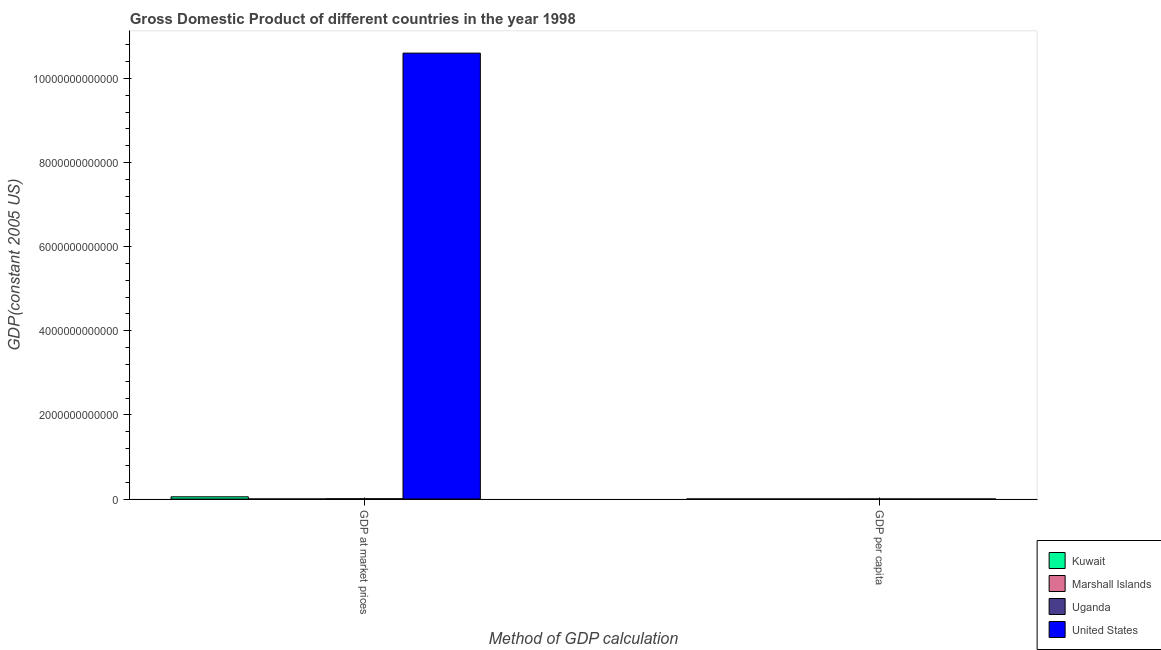How many different coloured bars are there?
Provide a succinct answer. 4. Are the number of bars per tick equal to the number of legend labels?
Make the answer very short. Yes. How many bars are there on the 1st tick from the left?
Give a very brief answer. 4. How many bars are there on the 1st tick from the right?
Your answer should be compact. 4. What is the label of the 1st group of bars from the left?
Your answer should be very brief. GDP at market prices. What is the gdp at market prices in Kuwait?
Make the answer very short. 5.30e+1. Across all countries, what is the maximum gdp at market prices?
Give a very brief answer. 1.06e+13. Across all countries, what is the minimum gdp per capita?
Your answer should be compact. 261.82. In which country was the gdp per capita minimum?
Offer a terse response. Uganda. What is the total gdp per capita in the graph?
Your answer should be very brief. 7.10e+04. What is the difference between the gdp at market prices in Marshall Islands and that in United States?
Offer a terse response. -1.06e+13. What is the difference between the gdp per capita in Uganda and the gdp at market prices in United States?
Offer a very short reply. -1.06e+13. What is the average gdp per capita per country?
Offer a very short reply. 1.77e+04. What is the difference between the gdp per capita and gdp at market prices in United States?
Offer a terse response. -1.06e+13. What is the ratio of the gdp at market prices in United States to that in Uganda?
Provide a short and direct response. 1812.95. In how many countries, is the gdp per capita greater than the average gdp per capita taken over all countries?
Keep it short and to the point. 2. What does the 2nd bar from the left in GDP per capita represents?
Your answer should be very brief. Marshall Islands. What does the 2nd bar from the right in GDP per capita represents?
Provide a short and direct response. Uganda. How many bars are there?
Provide a succinct answer. 8. Are all the bars in the graph horizontal?
Your answer should be very brief. No. What is the difference between two consecutive major ticks on the Y-axis?
Your answer should be very brief. 2.00e+12. Where does the legend appear in the graph?
Offer a very short reply. Bottom right. How are the legend labels stacked?
Ensure brevity in your answer.  Vertical. What is the title of the graph?
Offer a terse response. Gross Domestic Product of different countries in the year 1998. What is the label or title of the X-axis?
Provide a succinct answer. Method of GDP calculation. What is the label or title of the Y-axis?
Your answer should be very brief. GDP(constant 2005 US). What is the GDP(constant 2005 US) of Kuwait in GDP at market prices?
Make the answer very short. 5.30e+1. What is the GDP(constant 2005 US) of Marshall Islands in GDP at market prices?
Your answer should be compact. 1.20e+08. What is the GDP(constant 2005 US) of Uganda in GDP at market prices?
Make the answer very short. 5.85e+09. What is the GDP(constant 2005 US) of United States in GDP at market prices?
Your answer should be very brief. 1.06e+13. What is the GDP(constant 2005 US) of Kuwait in GDP per capita?
Offer a terse response. 3.00e+04. What is the GDP(constant 2005 US) in Marshall Islands in GDP per capita?
Your answer should be compact. 2307.91. What is the GDP(constant 2005 US) in Uganda in GDP per capita?
Provide a succinct answer. 261.82. What is the GDP(constant 2005 US) of United States in GDP per capita?
Provide a succinct answer. 3.84e+04. Across all Method of GDP calculation, what is the maximum GDP(constant 2005 US) of Kuwait?
Your answer should be compact. 5.30e+1. Across all Method of GDP calculation, what is the maximum GDP(constant 2005 US) in Marshall Islands?
Provide a succinct answer. 1.20e+08. Across all Method of GDP calculation, what is the maximum GDP(constant 2005 US) in Uganda?
Your answer should be very brief. 5.85e+09. Across all Method of GDP calculation, what is the maximum GDP(constant 2005 US) in United States?
Your response must be concise. 1.06e+13. Across all Method of GDP calculation, what is the minimum GDP(constant 2005 US) in Kuwait?
Provide a succinct answer. 3.00e+04. Across all Method of GDP calculation, what is the minimum GDP(constant 2005 US) of Marshall Islands?
Provide a short and direct response. 2307.91. Across all Method of GDP calculation, what is the minimum GDP(constant 2005 US) of Uganda?
Your response must be concise. 261.82. Across all Method of GDP calculation, what is the minimum GDP(constant 2005 US) of United States?
Give a very brief answer. 3.84e+04. What is the total GDP(constant 2005 US) of Kuwait in the graph?
Offer a terse response. 5.30e+1. What is the total GDP(constant 2005 US) of Marshall Islands in the graph?
Offer a very short reply. 1.20e+08. What is the total GDP(constant 2005 US) in Uganda in the graph?
Keep it short and to the point. 5.85e+09. What is the total GDP(constant 2005 US) in United States in the graph?
Your response must be concise. 1.06e+13. What is the difference between the GDP(constant 2005 US) of Kuwait in GDP at market prices and that in GDP per capita?
Give a very brief answer. 5.30e+1. What is the difference between the GDP(constant 2005 US) in Marshall Islands in GDP at market prices and that in GDP per capita?
Make the answer very short. 1.20e+08. What is the difference between the GDP(constant 2005 US) of Uganda in GDP at market prices and that in GDP per capita?
Offer a terse response. 5.85e+09. What is the difference between the GDP(constant 2005 US) in United States in GDP at market prices and that in GDP per capita?
Make the answer very short. 1.06e+13. What is the difference between the GDP(constant 2005 US) of Kuwait in GDP at market prices and the GDP(constant 2005 US) of Marshall Islands in GDP per capita?
Your answer should be very brief. 5.30e+1. What is the difference between the GDP(constant 2005 US) in Kuwait in GDP at market prices and the GDP(constant 2005 US) in Uganda in GDP per capita?
Give a very brief answer. 5.30e+1. What is the difference between the GDP(constant 2005 US) in Kuwait in GDP at market prices and the GDP(constant 2005 US) in United States in GDP per capita?
Provide a succinct answer. 5.30e+1. What is the difference between the GDP(constant 2005 US) of Marshall Islands in GDP at market prices and the GDP(constant 2005 US) of Uganda in GDP per capita?
Offer a terse response. 1.20e+08. What is the difference between the GDP(constant 2005 US) in Marshall Islands in GDP at market prices and the GDP(constant 2005 US) in United States in GDP per capita?
Ensure brevity in your answer.  1.20e+08. What is the difference between the GDP(constant 2005 US) in Uganda in GDP at market prices and the GDP(constant 2005 US) in United States in GDP per capita?
Your answer should be very brief. 5.85e+09. What is the average GDP(constant 2005 US) of Kuwait per Method of GDP calculation?
Ensure brevity in your answer.  2.65e+1. What is the average GDP(constant 2005 US) of Marshall Islands per Method of GDP calculation?
Provide a short and direct response. 5.99e+07. What is the average GDP(constant 2005 US) of Uganda per Method of GDP calculation?
Keep it short and to the point. 2.92e+09. What is the average GDP(constant 2005 US) of United States per Method of GDP calculation?
Your answer should be very brief. 5.30e+12. What is the difference between the GDP(constant 2005 US) in Kuwait and GDP(constant 2005 US) in Marshall Islands in GDP at market prices?
Offer a terse response. 5.28e+1. What is the difference between the GDP(constant 2005 US) in Kuwait and GDP(constant 2005 US) in Uganda in GDP at market prices?
Your response must be concise. 4.71e+1. What is the difference between the GDP(constant 2005 US) of Kuwait and GDP(constant 2005 US) of United States in GDP at market prices?
Keep it short and to the point. -1.05e+13. What is the difference between the GDP(constant 2005 US) of Marshall Islands and GDP(constant 2005 US) of Uganda in GDP at market prices?
Keep it short and to the point. -5.73e+09. What is the difference between the GDP(constant 2005 US) in Marshall Islands and GDP(constant 2005 US) in United States in GDP at market prices?
Provide a short and direct response. -1.06e+13. What is the difference between the GDP(constant 2005 US) in Uganda and GDP(constant 2005 US) in United States in GDP at market prices?
Your answer should be compact. -1.06e+13. What is the difference between the GDP(constant 2005 US) in Kuwait and GDP(constant 2005 US) in Marshall Islands in GDP per capita?
Provide a short and direct response. 2.77e+04. What is the difference between the GDP(constant 2005 US) in Kuwait and GDP(constant 2005 US) in Uganda in GDP per capita?
Keep it short and to the point. 2.97e+04. What is the difference between the GDP(constant 2005 US) of Kuwait and GDP(constant 2005 US) of United States in GDP per capita?
Your response must be concise. -8455.79. What is the difference between the GDP(constant 2005 US) in Marshall Islands and GDP(constant 2005 US) in Uganda in GDP per capita?
Your answer should be very brief. 2046.09. What is the difference between the GDP(constant 2005 US) in Marshall Islands and GDP(constant 2005 US) in United States in GDP per capita?
Offer a very short reply. -3.61e+04. What is the difference between the GDP(constant 2005 US) in Uganda and GDP(constant 2005 US) in United States in GDP per capita?
Make the answer very short. -3.82e+04. What is the ratio of the GDP(constant 2005 US) of Kuwait in GDP at market prices to that in GDP per capita?
Make the answer very short. 1.77e+06. What is the ratio of the GDP(constant 2005 US) of Marshall Islands in GDP at market prices to that in GDP per capita?
Your response must be concise. 5.19e+04. What is the ratio of the GDP(constant 2005 US) of Uganda in GDP at market prices to that in GDP per capita?
Keep it short and to the point. 2.23e+07. What is the ratio of the GDP(constant 2005 US) in United States in GDP at market prices to that in GDP per capita?
Your answer should be compact. 2.76e+08. What is the difference between the highest and the second highest GDP(constant 2005 US) of Kuwait?
Provide a succinct answer. 5.30e+1. What is the difference between the highest and the second highest GDP(constant 2005 US) of Marshall Islands?
Ensure brevity in your answer.  1.20e+08. What is the difference between the highest and the second highest GDP(constant 2005 US) in Uganda?
Give a very brief answer. 5.85e+09. What is the difference between the highest and the second highest GDP(constant 2005 US) in United States?
Your answer should be compact. 1.06e+13. What is the difference between the highest and the lowest GDP(constant 2005 US) of Kuwait?
Provide a succinct answer. 5.30e+1. What is the difference between the highest and the lowest GDP(constant 2005 US) in Marshall Islands?
Your answer should be very brief. 1.20e+08. What is the difference between the highest and the lowest GDP(constant 2005 US) of Uganda?
Offer a very short reply. 5.85e+09. What is the difference between the highest and the lowest GDP(constant 2005 US) of United States?
Provide a short and direct response. 1.06e+13. 